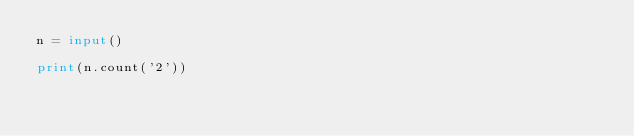Convert code to text. <code><loc_0><loc_0><loc_500><loc_500><_Python_>n = input()

print(n.count('2'))</code> 